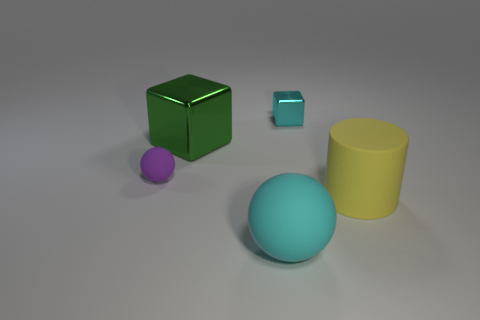How many things are either small blue matte cylinders or rubber spheres?
Your answer should be compact. 2. Are there an equal number of big cyan rubber spheres behind the tiny purple matte thing and big blue metal balls?
Your response must be concise. Yes. Are there any tiny things that are left of the small object to the right of the metal thing that is in front of the small cube?
Offer a terse response. Yes. What is the color of the big thing that is made of the same material as the big cylinder?
Provide a short and direct response. Cyan. Do the shiny block that is on the left side of the big cyan thing and the small ball have the same color?
Your answer should be very brief. No. How many balls are small purple rubber objects or yellow matte things?
Ensure brevity in your answer.  1. There is a rubber thing in front of the large rubber object to the right of the tiny thing behind the small purple ball; what is its size?
Ensure brevity in your answer.  Large. The yellow object that is the same size as the cyan sphere is what shape?
Offer a terse response. Cylinder. The large cyan thing has what shape?
Provide a short and direct response. Sphere. Is the sphere to the left of the green thing made of the same material as the small block?
Your answer should be very brief. No. 